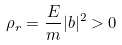<formula> <loc_0><loc_0><loc_500><loc_500>\rho _ { r } = \frac { E } { m } | b | ^ { 2 } > 0</formula> 